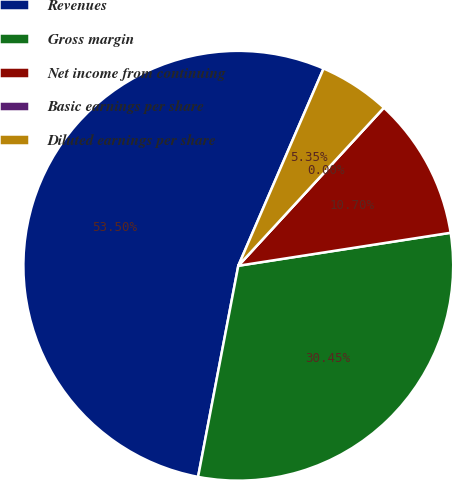Convert chart. <chart><loc_0><loc_0><loc_500><loc_500><pie_chart><fcel>Revenues<fcel>Gross margin<fcel>Net income from continuing<fcel>Basic earnings per share<fcel>Diluted earnings per share<nl><fcel>53.5%<fcel>30.45%<fcel>10.7%<fcel>0.0%<fcel>5.35%<nl></chart> 